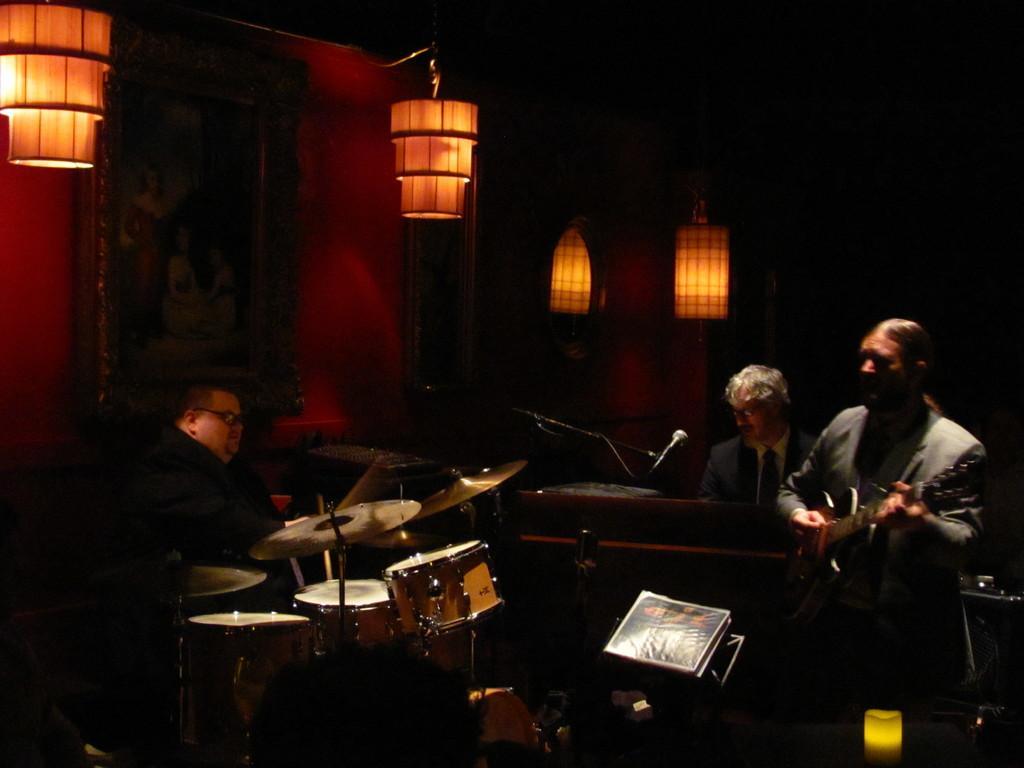In one or two sentences, can you explain what this image depicts? In this image we can see people playing musical instruments. There are mics placed on the stands. We can see a stand. In the background there are lights and a wall. We can see a frame placed on the wall. 